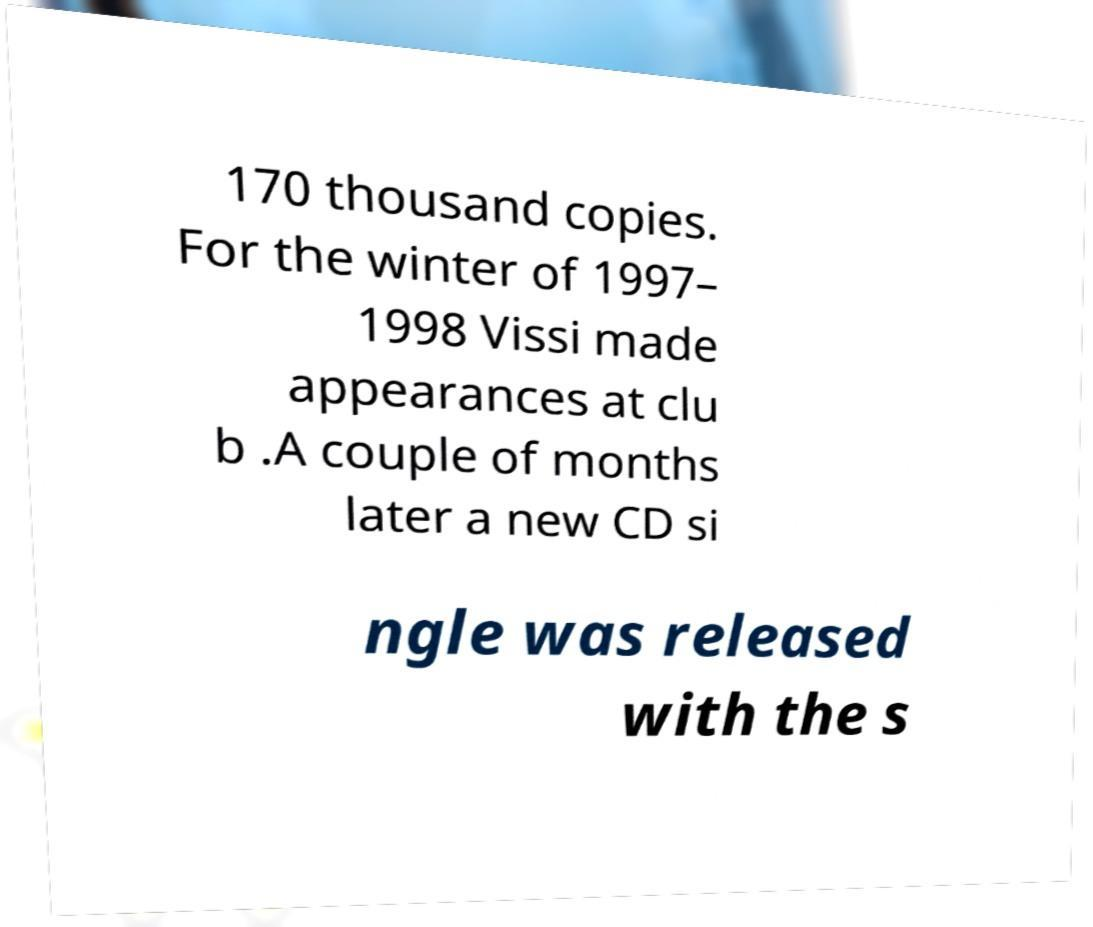What messages or text are displayed in this image? I need them in a readable, typed format. 170 thousand copies. For the winter of 1997– 1998 Vissi made appearances at clu b .A couple of months later a new CD si ngle was released with the s 